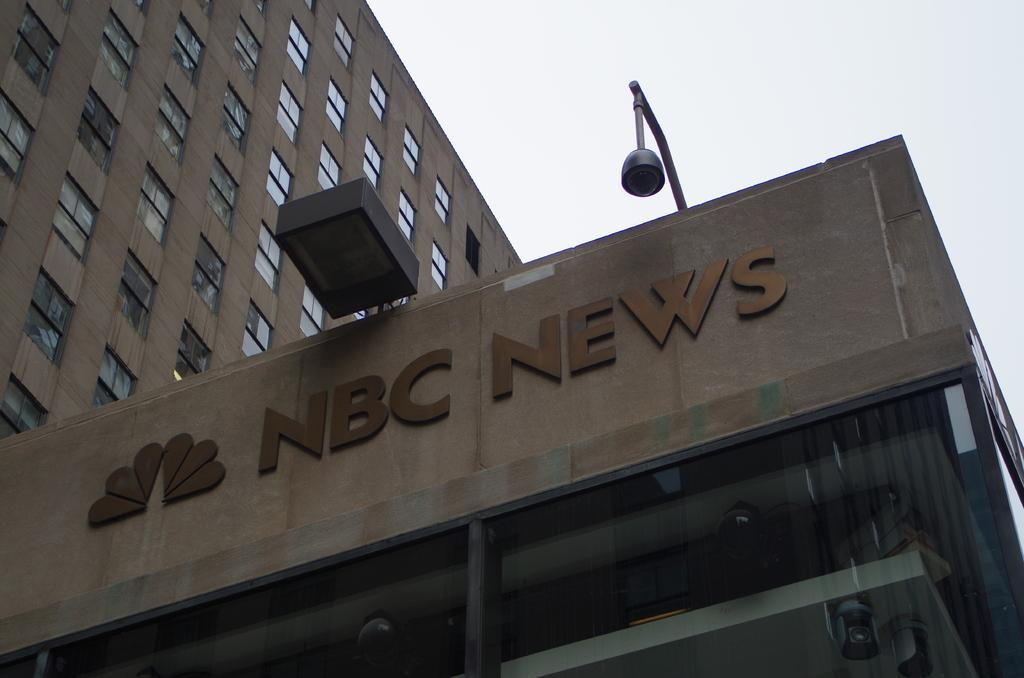What type of structure is visible in the image? There is a building with windows in the image. What is attached to the building in the image? There is a camera with a pole attached to the building in the image. What information is displayed on the building? The building has a name and emblem on it. What can be seen in the background of the image? The sky is visible in the background of the image. How many balls are being juggled by the kite in the image? There is no kite or balls present in the image. 